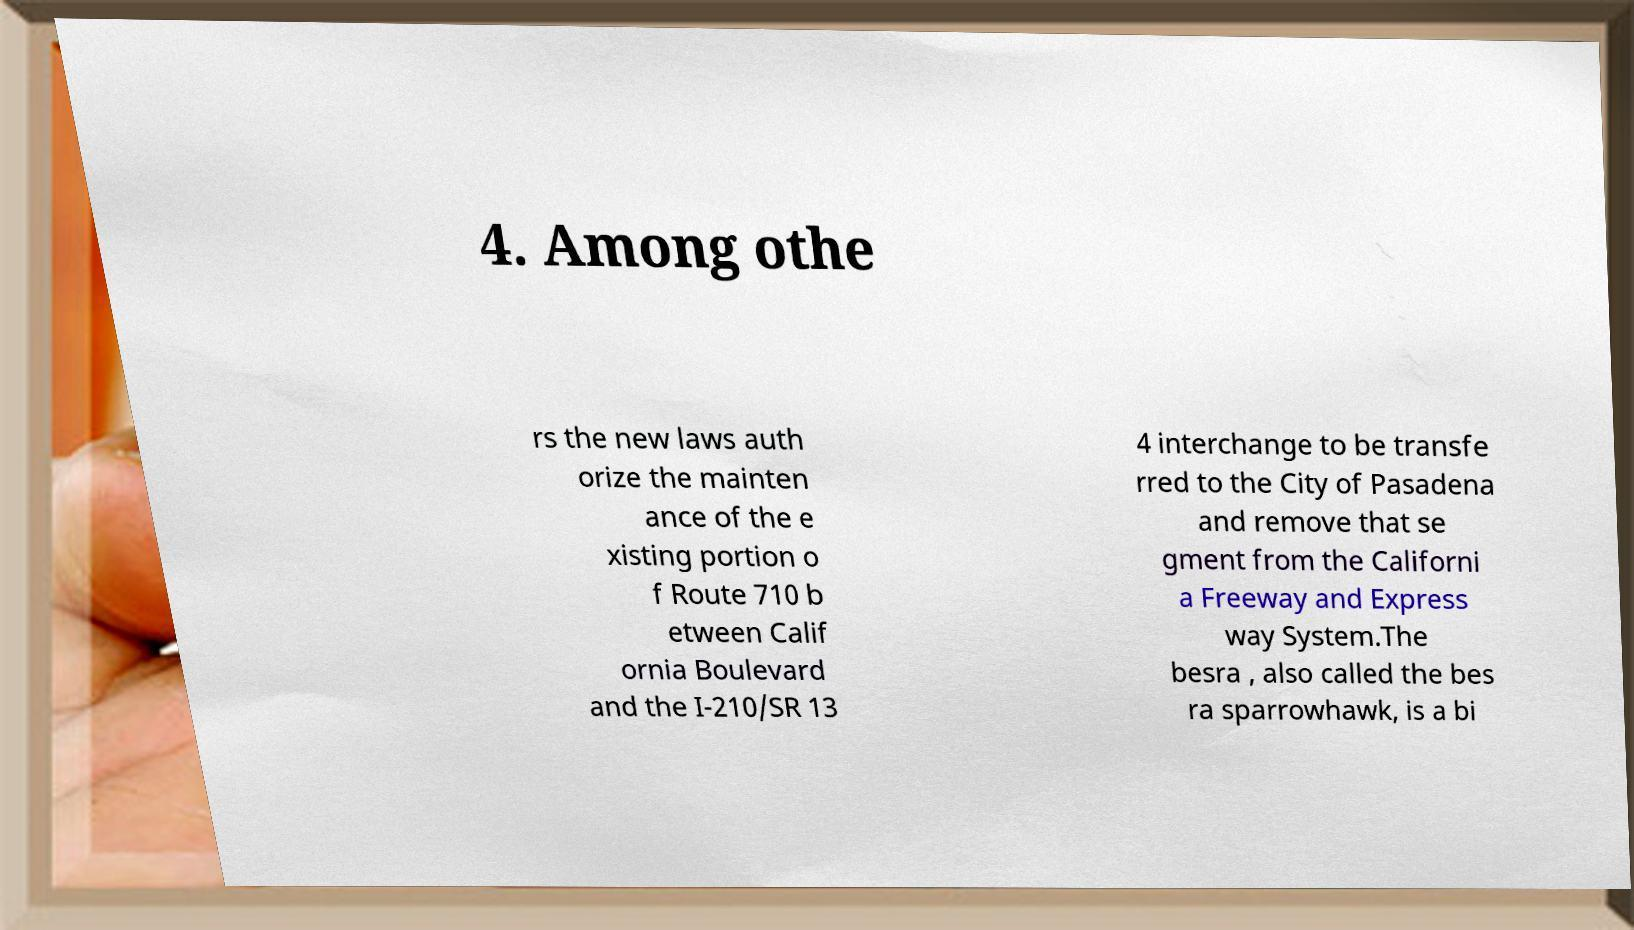Can you read and provide the text displayed in the image?This photo seems to have some interesting text. Can you extract and type it out for me? 4. Among othe rs the new laws auth orize the mainten ance of the e xisting portion o f Route 710 b etween Calif ornia Boulevard and the I-210/SR 13 4 interchange to be transfe rred to the City of Pasadena and remove that se gment from the Californi a Freeway and Express way System.The besra , also called the bes ra sparrowhawk, is a bi 